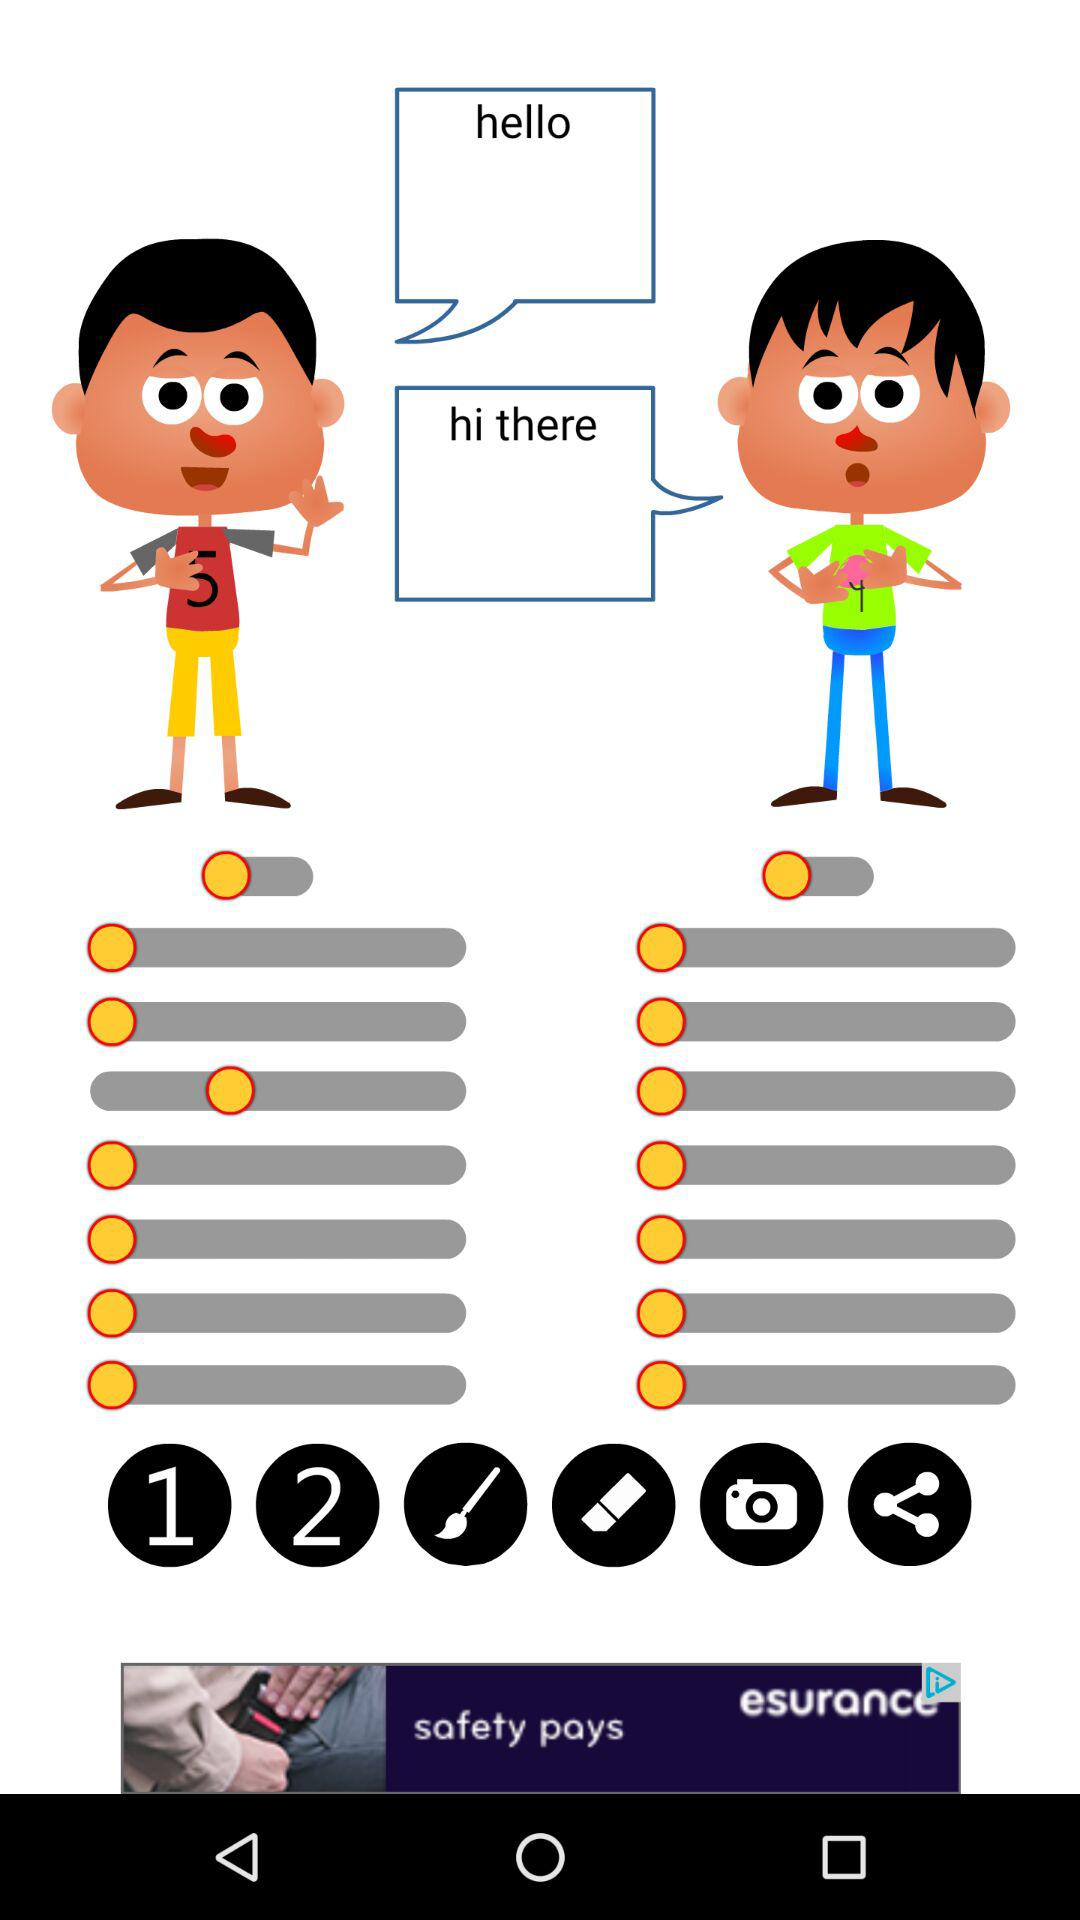How many rows of gray lines with yellow circles are there?
Answer the question using a single word or phrase. 2 